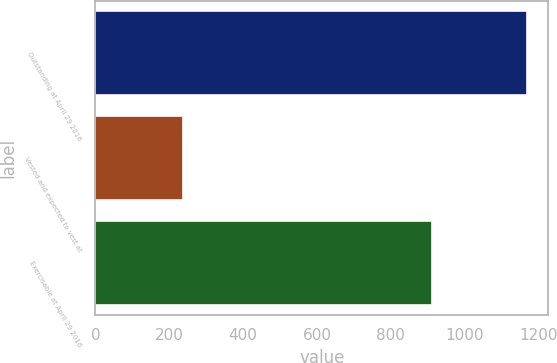<chart> <loc_0><loc_0><loc_500><loc_500><bar_chart><fcel>Outstanding at April 29 2016<fcel>Vested and expected to vest at<fcel>Exercisable at April 29 2016<nl><fcel>1168<fcel>236<fcel>912<nl></chart> 